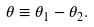Convert formula to latex. <formula><loc_0><loc_0><loc_500><loc_500>\theta \equiv \theta _ { 1 } - \theta _ { 2 } .</formula> 